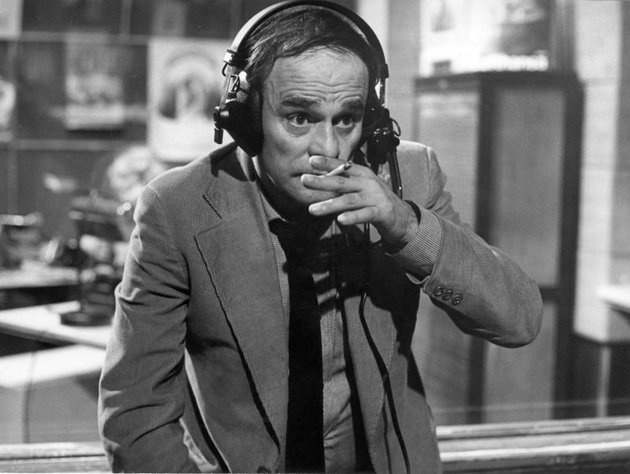Write a detailed description of the given image. This black and white photograph features a man who is centrally positioned, likely Roman Wilhelmi, an actor, portraying a radio DJ. He is attired in a formal suit and tie, exuding a professional aura, with a pair of headphones snugly fitted over his head, suggesting he is either engaged in listening or preparing for a broadcast. With an informal touch, he holds a cigarette in his right hand, juxtaposing his professional attire. He appears to be speaking into a microphone, hinting at an ongoing live broadcast. The backdrop displays a typical radio studio environment filled with various pieces of equipment, signifying the technical intricacies involved in his work. On the wall behind him, posters can be seen, potentially reflecting the culture or thematic interests of the radio station. 